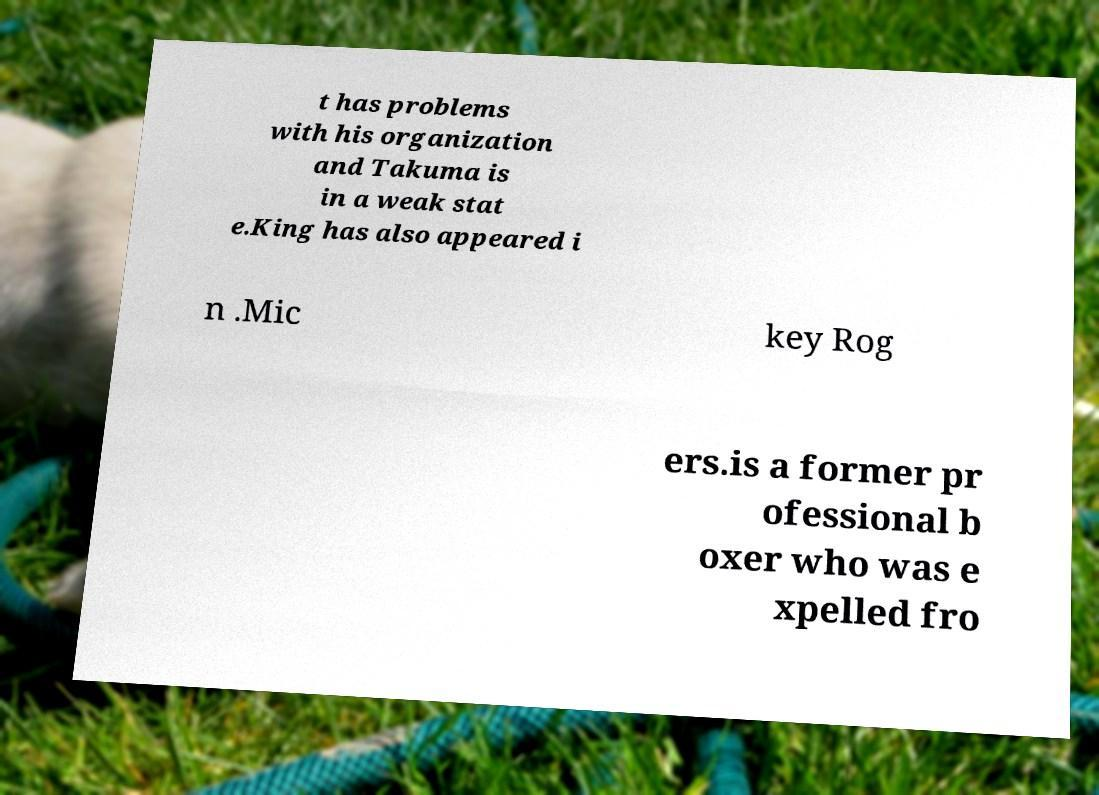I need the written content from this picture converted into text. Can you do that? t has problems with his organization and Takuma is in a weak stat e.King has also appeared i n .Mic key Rog ers.is a former pr ofessional b oxer who was e xpelled fro 